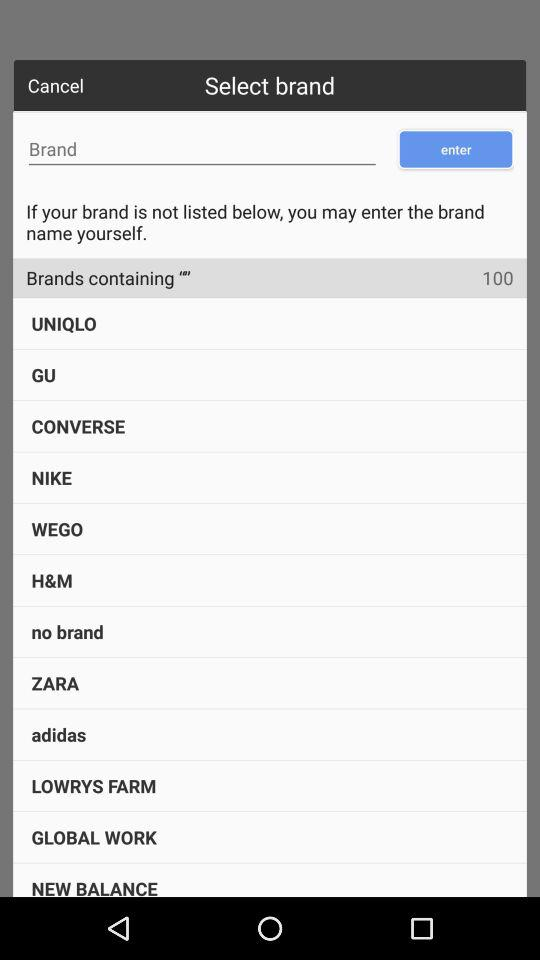What are the available brands? The available brands are "UNIQLO", "GU", "CONVERSE", "NIKE", "WEGO", "H&M", "no brand", "ZARA", "adidas", "LOWRYS FARM", "GLOBAL WORK" and "NEW BALANCE". 